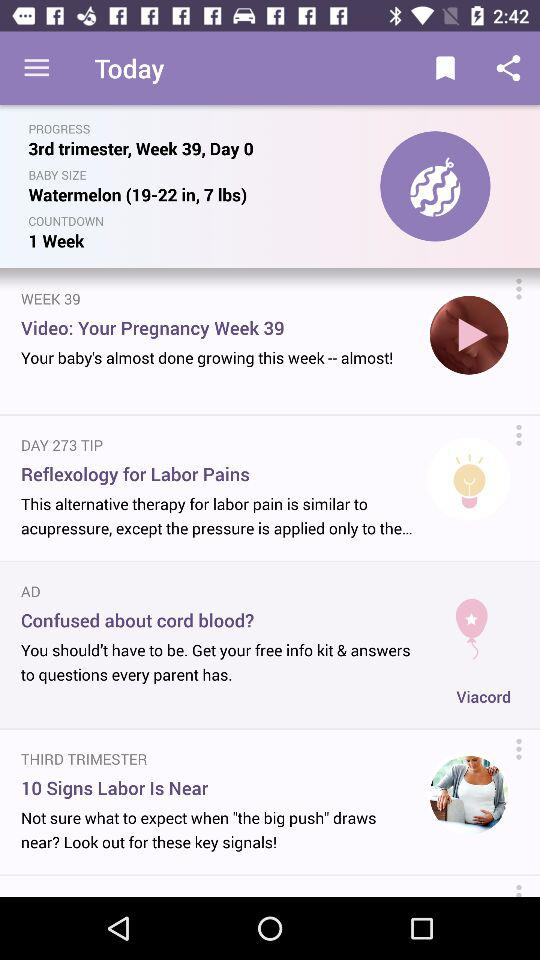What is the number of weeks left in the countdown? The number of weeks left in the countdown is 1. 